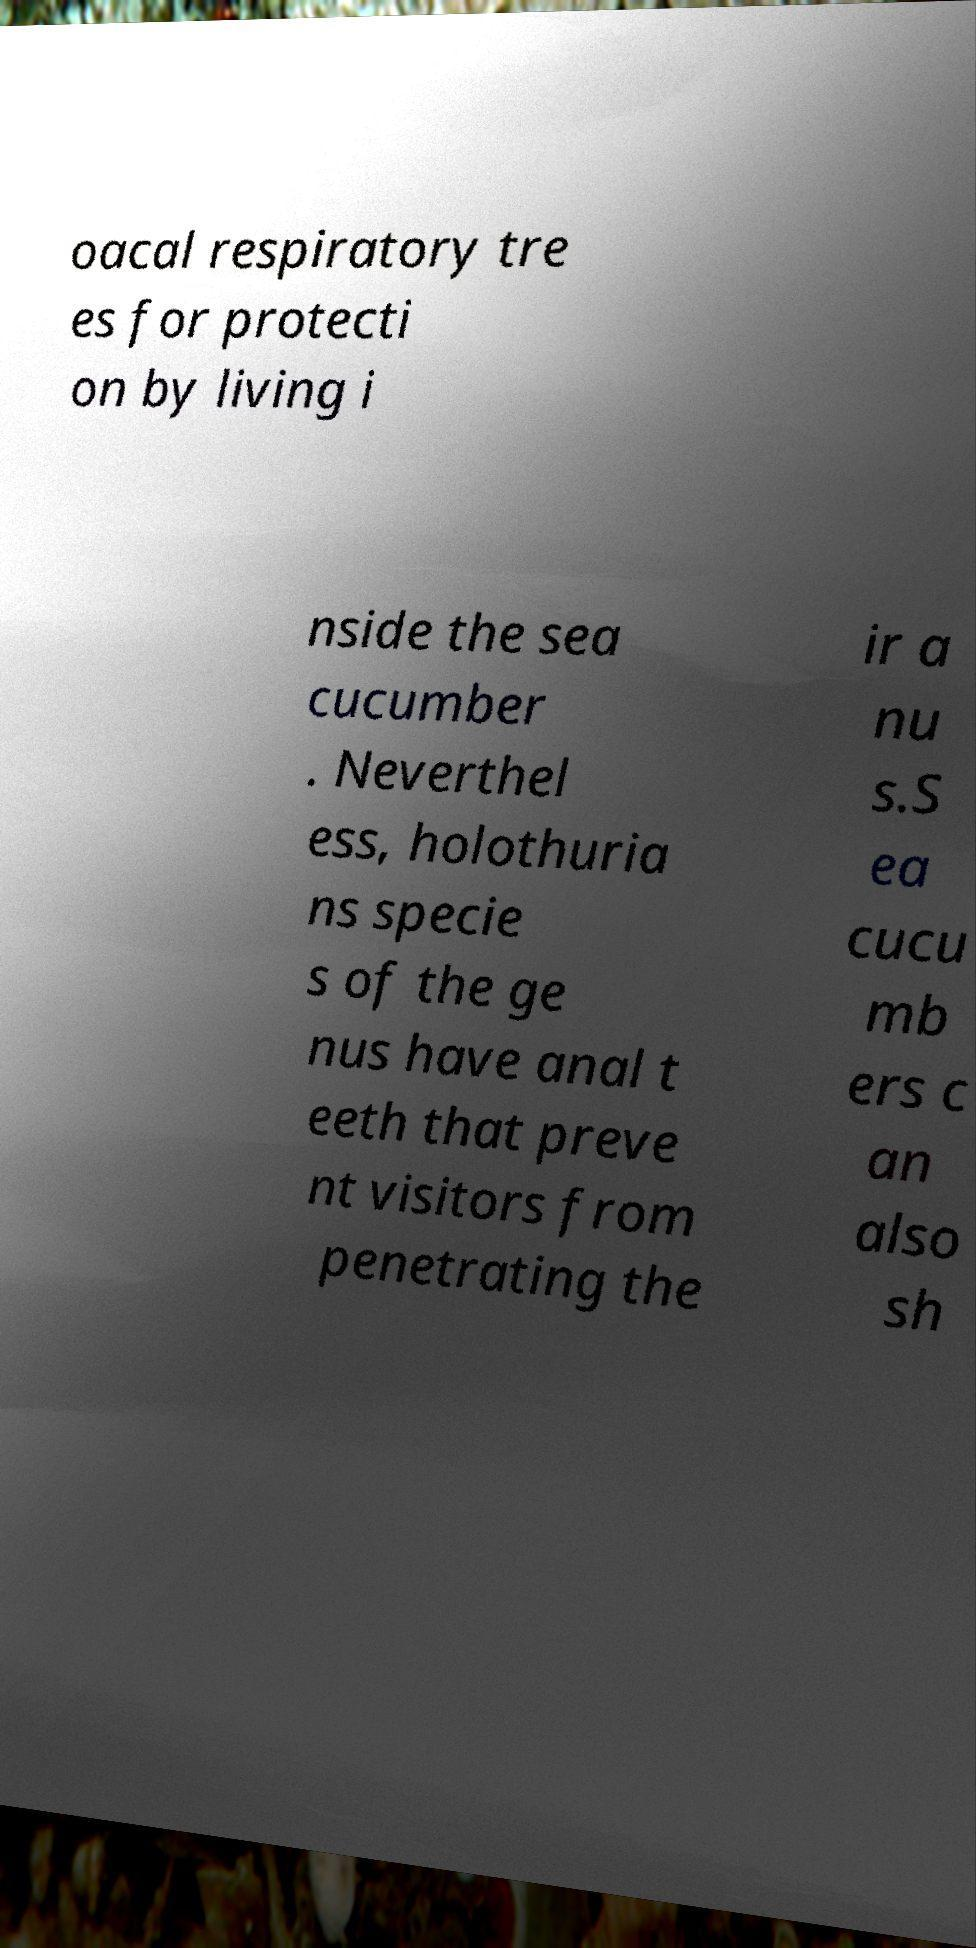There's text embedded in this image that I need extracted. Can you transcribe it verbatim? oacal respiratory tre es for protecti on by living i nside the sea cucumber . Neverthel ess, holothuria ns specie s of the ge nus have anal t eeth that preve nt visitors from penetrating the ir a nu s.S ea cucu mb ers c an also sh 